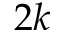Convert formula to latex. <formula><loc_0><loc_0><loc_500><loc_500>2 k</formula> 